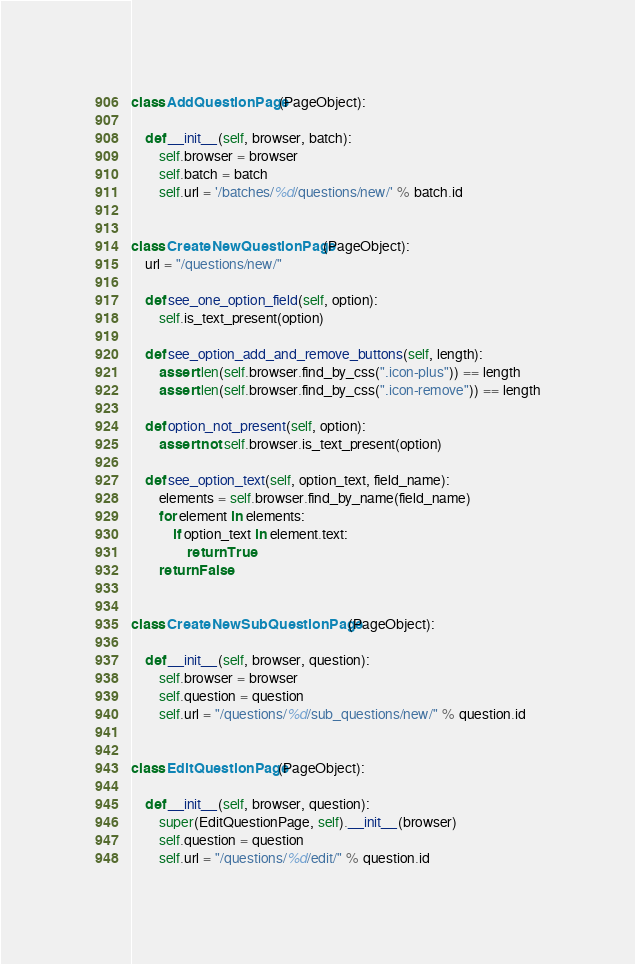<code> <loc_0><loc_0><loc_500><loc_500><_Python_>class AddQuestionPage(PageObject):

    def __init__(self, browser, batch):
        self.browser = browser
        self.batch = batch
        self.url = '/batches/%d/questions/new/' % batch.id


class CreateNewQuestionPage(PageObject):
    url = "/questions/new/"

    def see_one_option_field(self, option):
        self.is_text_present(option)

    def see_option_add_and_remove_buttons(self, length):
        assert len(self.browser.find_by_css(".icon-plus")) == length
        assert len(self.browser.find_by_css(".icon-remove")) == length

    def option_not_present(self, option):
        assert not self.browser.is_text_present(option)

    def see_option_text(self, option_text, field_name):
        elements = self.browser.find_by_name(field_name)
        for element in elements:
            if option_text in element.text:
                return True
        return False


class CreateNewSubQuestionPage(PageObject):

    def __init__(self, browser, question):
        self.browser = browser
        self.question = question
        self.url = "/questions/%d/sub_questions/new/" % question.id


class EditQuestionPage(PageObject):

    def __init__(self, browser, question):
        super(EditQuestionPage, self).__init__(browser)
        self.question = question
        self.url = "/questions/%d/edit/" % question.id
</code> 